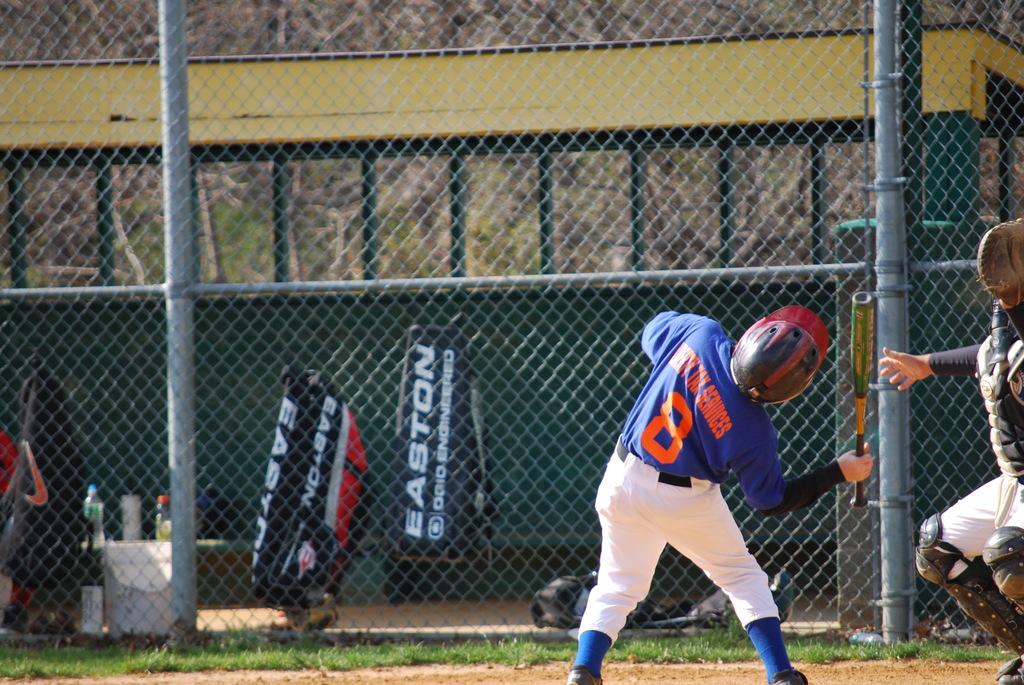What is the players number?
Offer a very short reply. 8. 